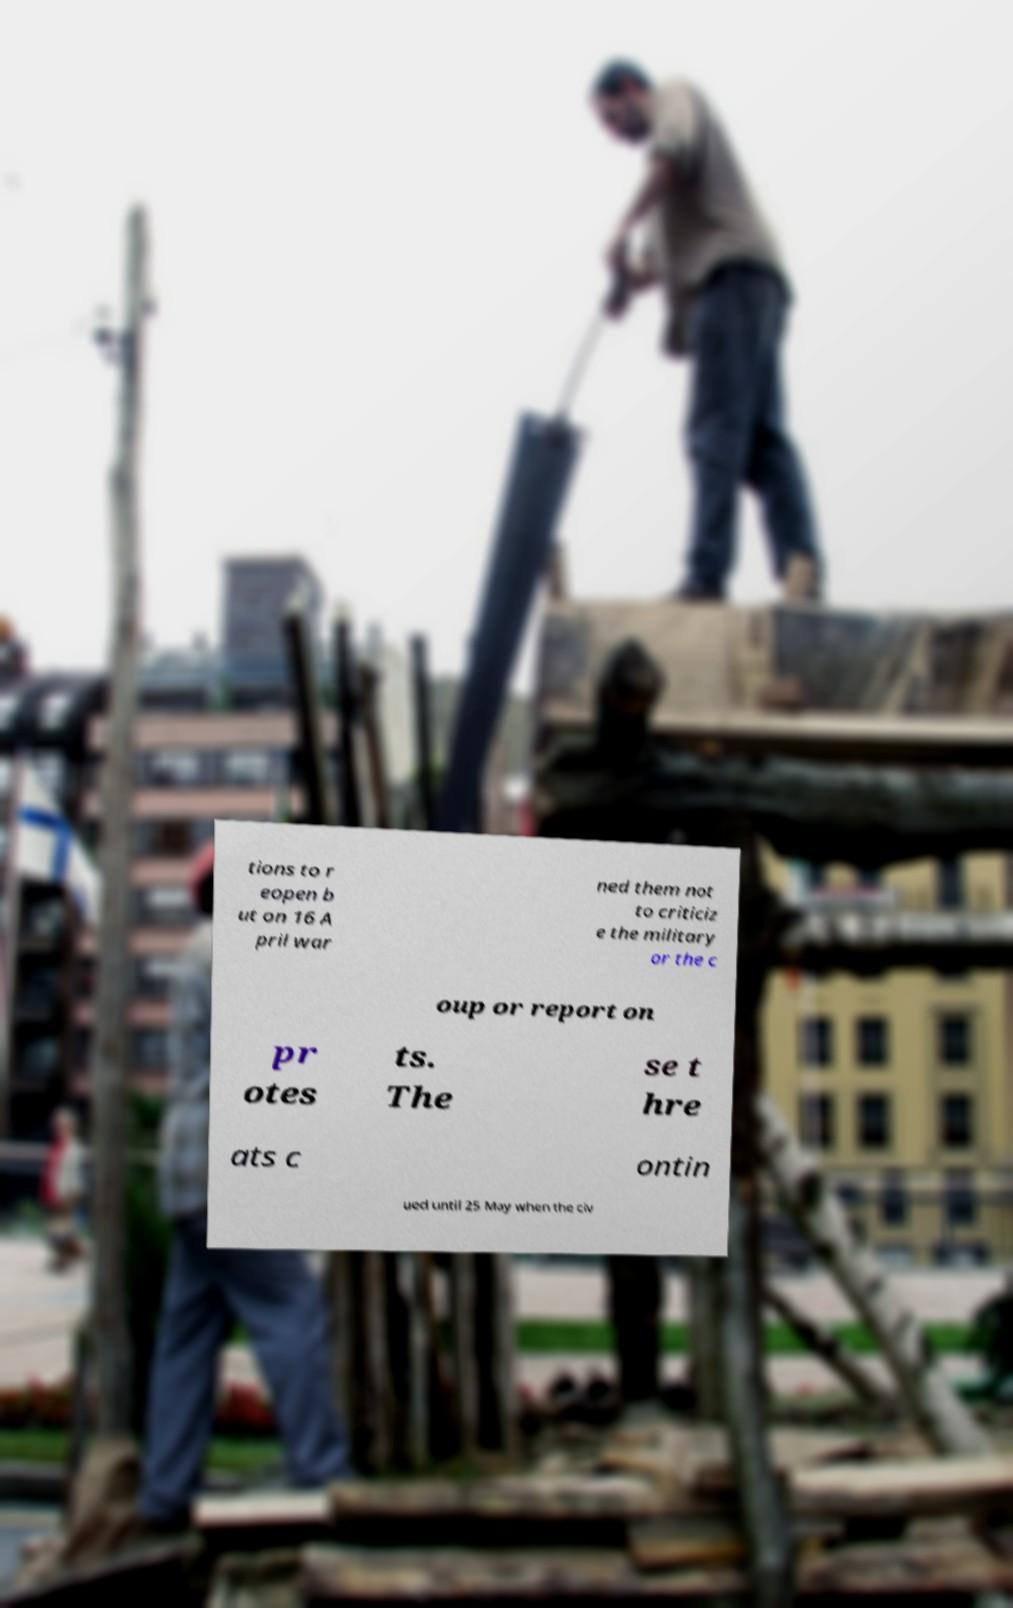Can you read and provide the text displayed in the image?This photo seems to have some interesting text. Can you extract and type it out for me? tions to r eopen b ut on 16 A pril war ned them not to criticiz e the military or the c oup or report on pr otes ts. The se t hre ats c ontin ued until 25 May when the civ 